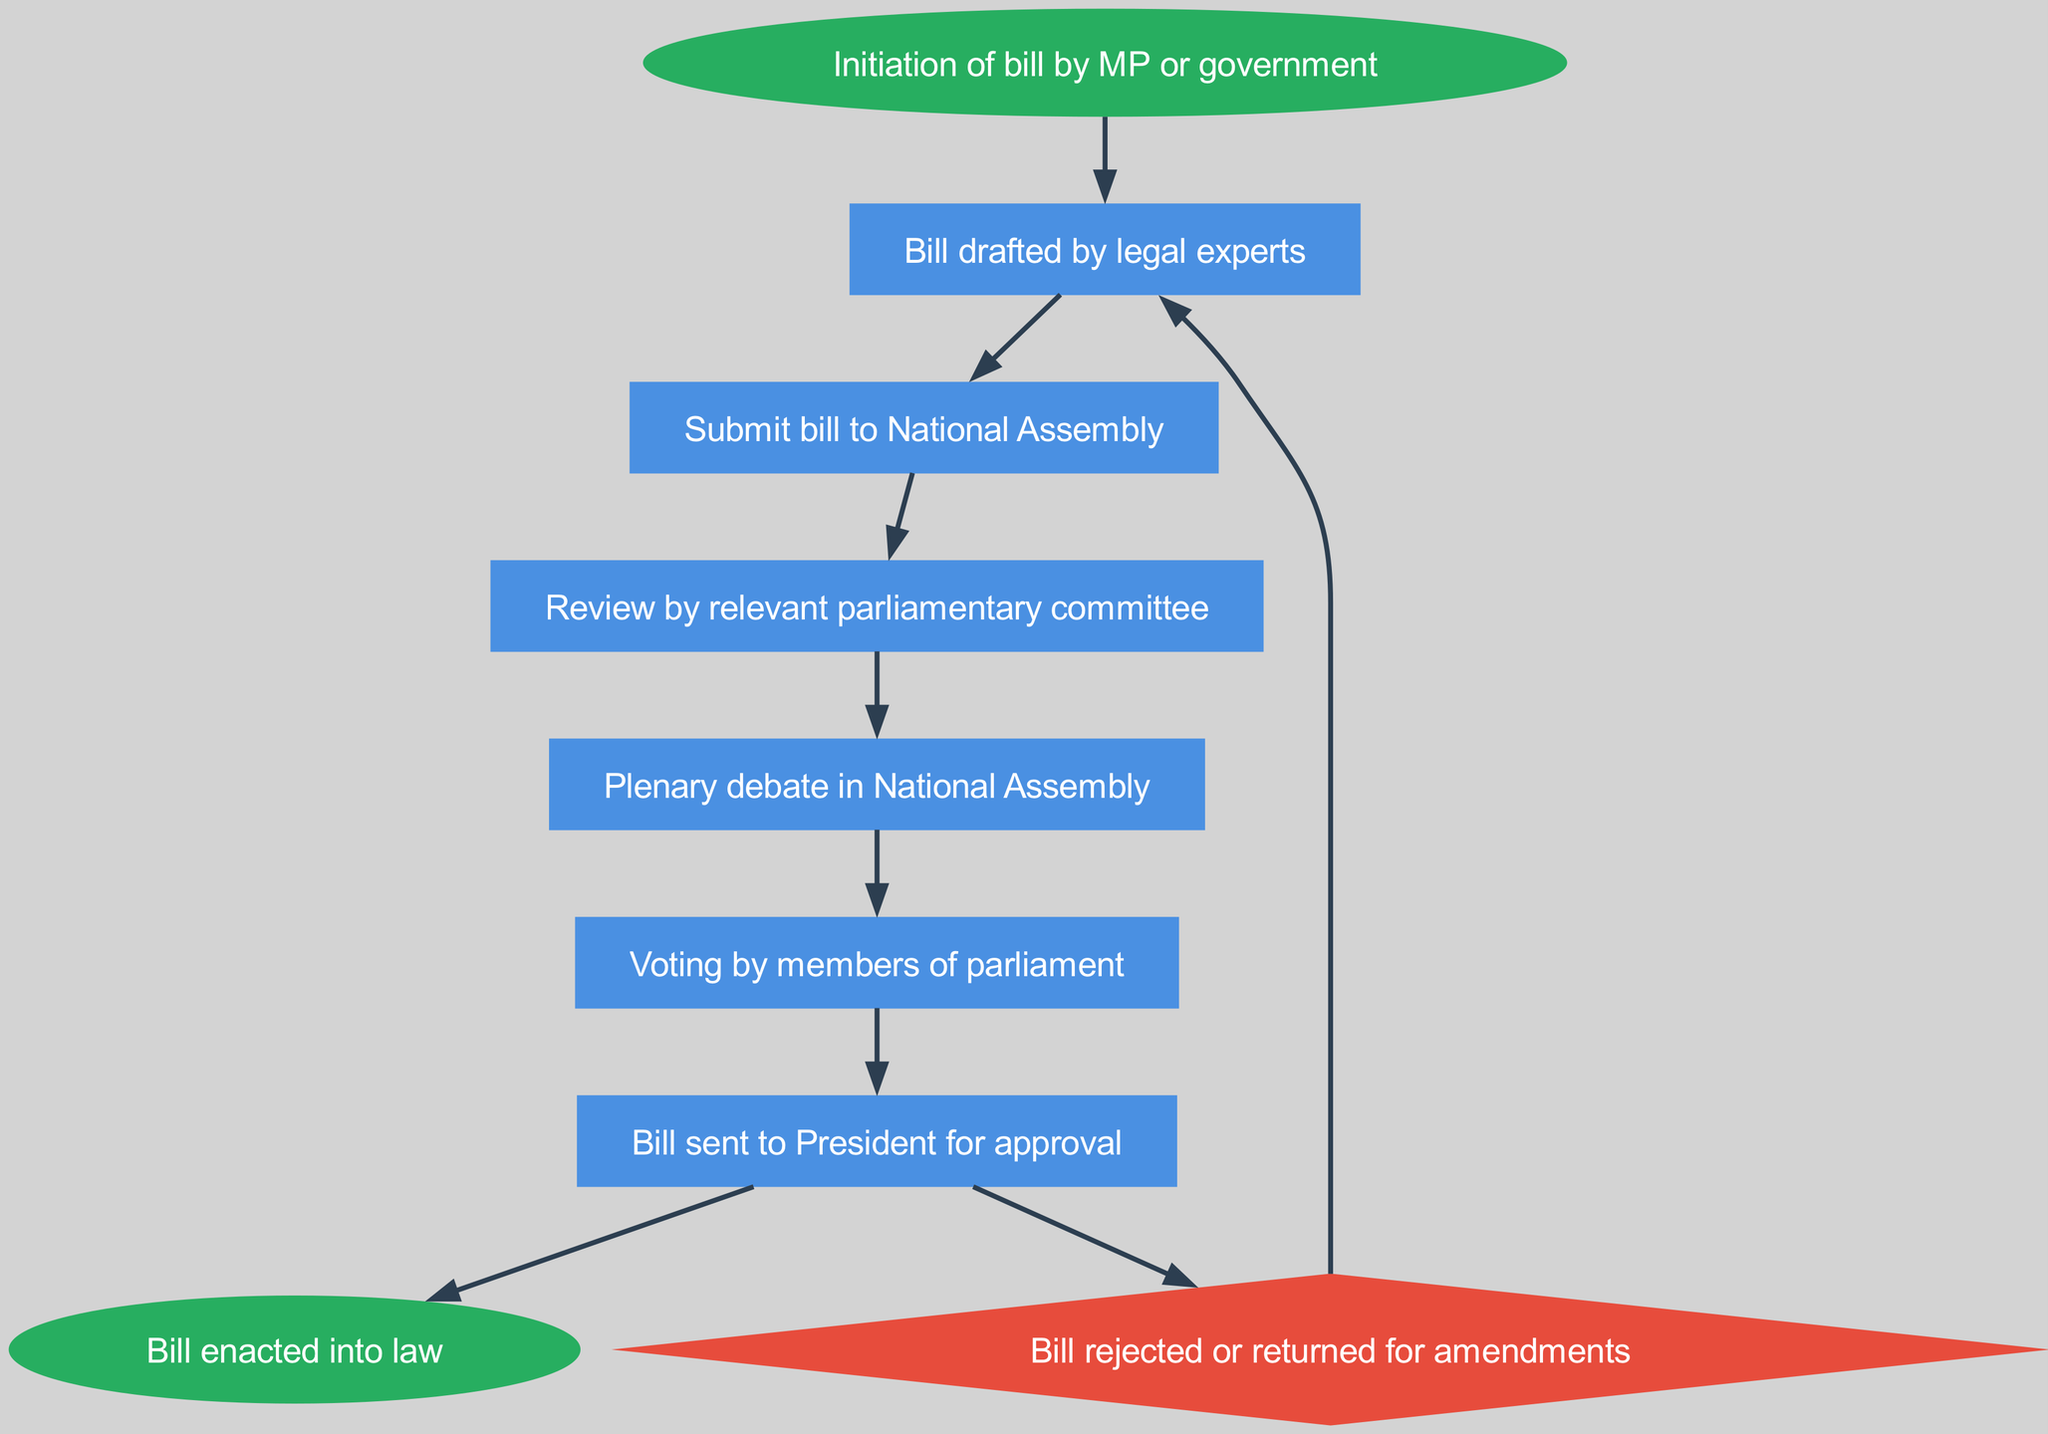What is the first step in the process of introducing a new bill? The first step according to the diagram is "Initiation of bill by MP or government." This is the starting point of the flow chart indicated by the 'start' node.
Answer: Initiation of bill by MP or government How many nodes are there in the diagram? By counting the individual steps or elements represented in the diagram, there are a total of 9 nodes. The nodes correspond to each step in the bill introduction process.
Answer: 9 What happens after the bill is drafted? According to the connections in the diagram, after the "Bill drafted by legal experts," the next step is "Submit bill to National Assembly." This indicates a clear progression in the process.
Answer: Submit bill to National Assembly How is the bill treated if it is rejected? If the bill is rejected, it is indicated in the diagram that it goes back to "Bill drafted by legal experts" for amendments, as shown by the connection from the "reject" node back to the "draft" node.
Answer: Bill drafted by legal experts What decision follows after the voting? The diagram shows that after the "Voting by members of parliament," the next step is to send the bill to the "President for approval," which indicates the governmental procedure following a parliamentary vote.
Answer: Bill sent to President for approval What is the last step if the bill is approved? If the bill receives approval from the President, the final step, as depicted in the diagram, is "Bill enacted into law." This shows the conclusion of the legislative process.
Answer: Bill enacted into law What role does the relevant parliamentary committee play? The diagram specifically outlines that the "Review by relevant parliamentary committee" is a key step that occurs after the bill is submitted to the National Assembly, indicating its evaluative function in the process.
Answer: Review by relevant parliamentary committee What shape is the 'reject' node represented as in the diagram? The 'reject' node is depicted as a diamond shape in the diagram, which typically symbolizes a decision point in flow charts, indicating a branching path based on approval or disapproval.
Answer: Diamond How does the process of introducing a new bill begin and end? The process starts with "Initiation of bill by MP or government" and ends with "Bill enacted into law," indicating a complete cycle from proposal to legislation.
Answer: Initiation of bill by MP or government and Bill enacted into law 